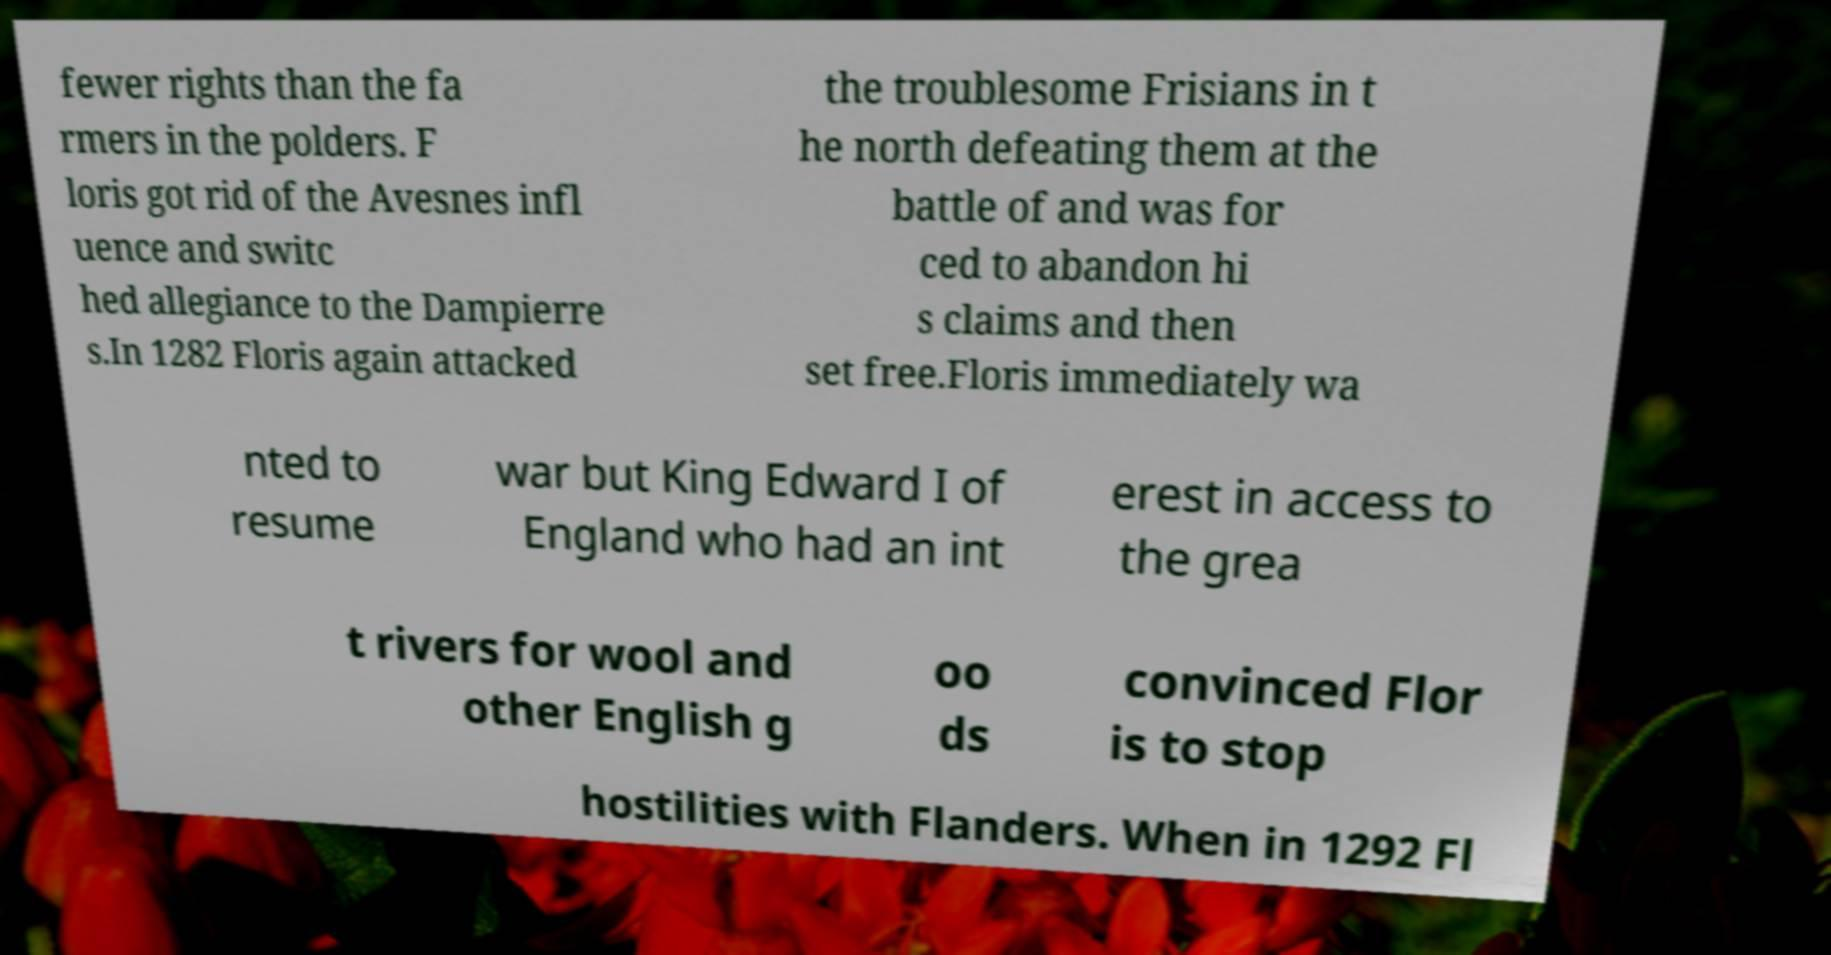Can you read and provide the text displayed in the image?This photo seems to have some interesting text. Can you extract and type it out for me? fewer rights than the fa rmers in the polders. F loris got rid of the Avesnes infl uence and switc hed allegiance to the Dampierre s.In 1282 Floris again attacked the troublesome Frisians in t he north defeating them at the battle of and was for ced to abandon hi s claims and then set free.Floris immediately wa nted to resume war but King Edward I of England who had an int erest in access to the grea t rivers for wool and other English g oo ds convinced Flor is to stop hostilities with Flanders. When in 1292 Fl 